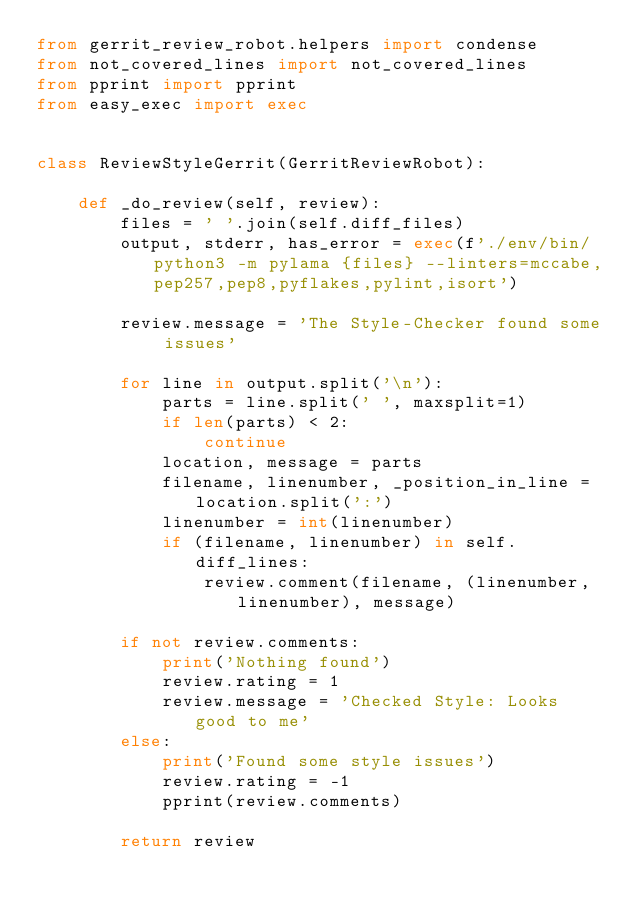<code> <loc_0><loc_0><loc_500><loc_500><_Python_>from gerrit_review_robot.helpers import condense
from not_covered_lines import not_covered_lines
from pprint import pprint
from easy_exec import exec


class ReviewStyleGerrit(GerritReviewRobot):

    def _do_review(self, review):
        files = ' '.join(self.diff_files)
        output, stderr, has_error = exec(f'./env/bin/python3 -m pylama {files} --linters=mccabe,pep257,pep8,pyflakes,pylint,isort')
        
        review.message = 'The Style-Checker found some issues'

        for line in output.split('\n'):
            parts = line.split(' ', maxsplit=1)
            if len(parts) < 2:
                continue
            location, message = parts
            filename, linenumber, _position_in_line = location.split(':')
            linenumber = int(linenumber)
            if (filename, linenumber) in self.diff_lines:
                review.comment(filename, (linenumber, linenumber), message)
        
        if not review.comments:
            print('Nothing found')
            review.rating = 1
            review.message = 'Checked Style: Looks good to me'
        else:
            print('Found some style issues')
            review.rating = -1
            pprint(review.comments)

        return review</code> 